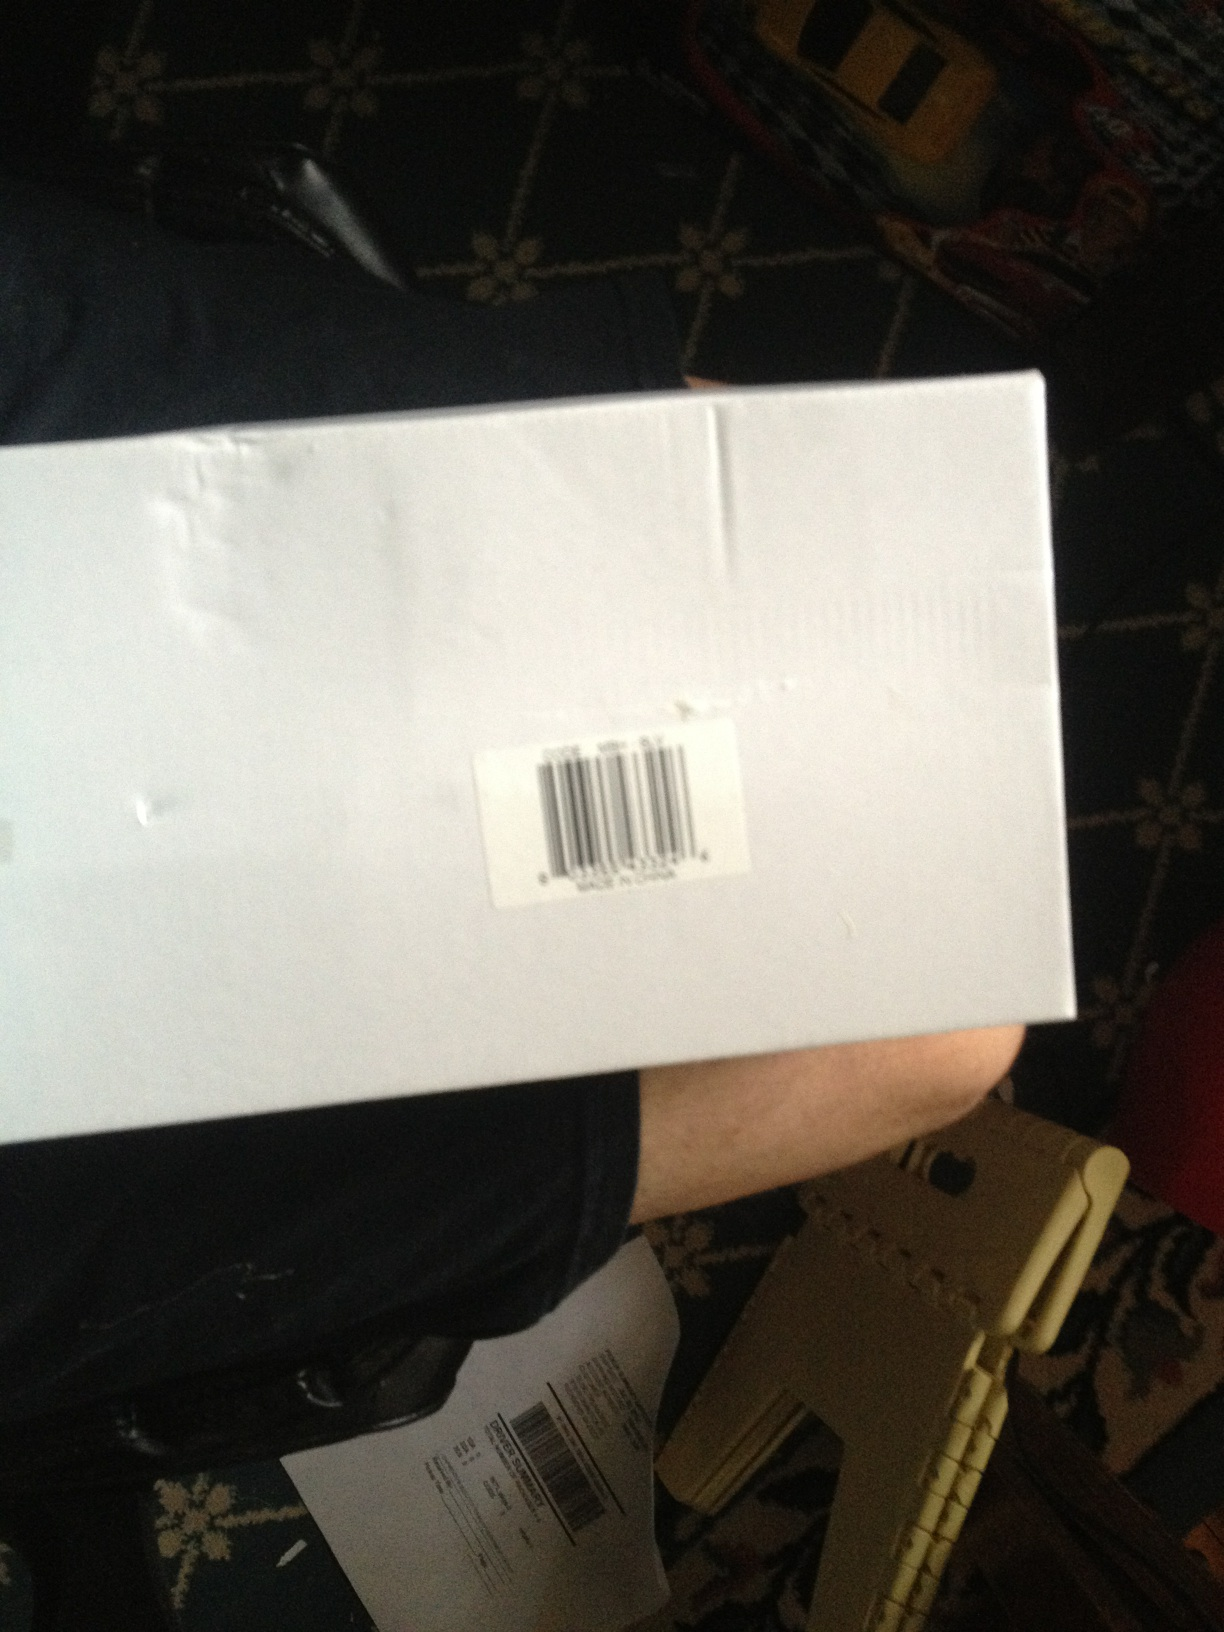What is this item? This appears to be a white box with a barcode label on it. It seems to be an item ready for shipping or storage, possibly containing a product or goods. 